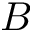Convert formula to latex. <formula><loc_0><loc_0><loc_500><loc_500>B</formula> 